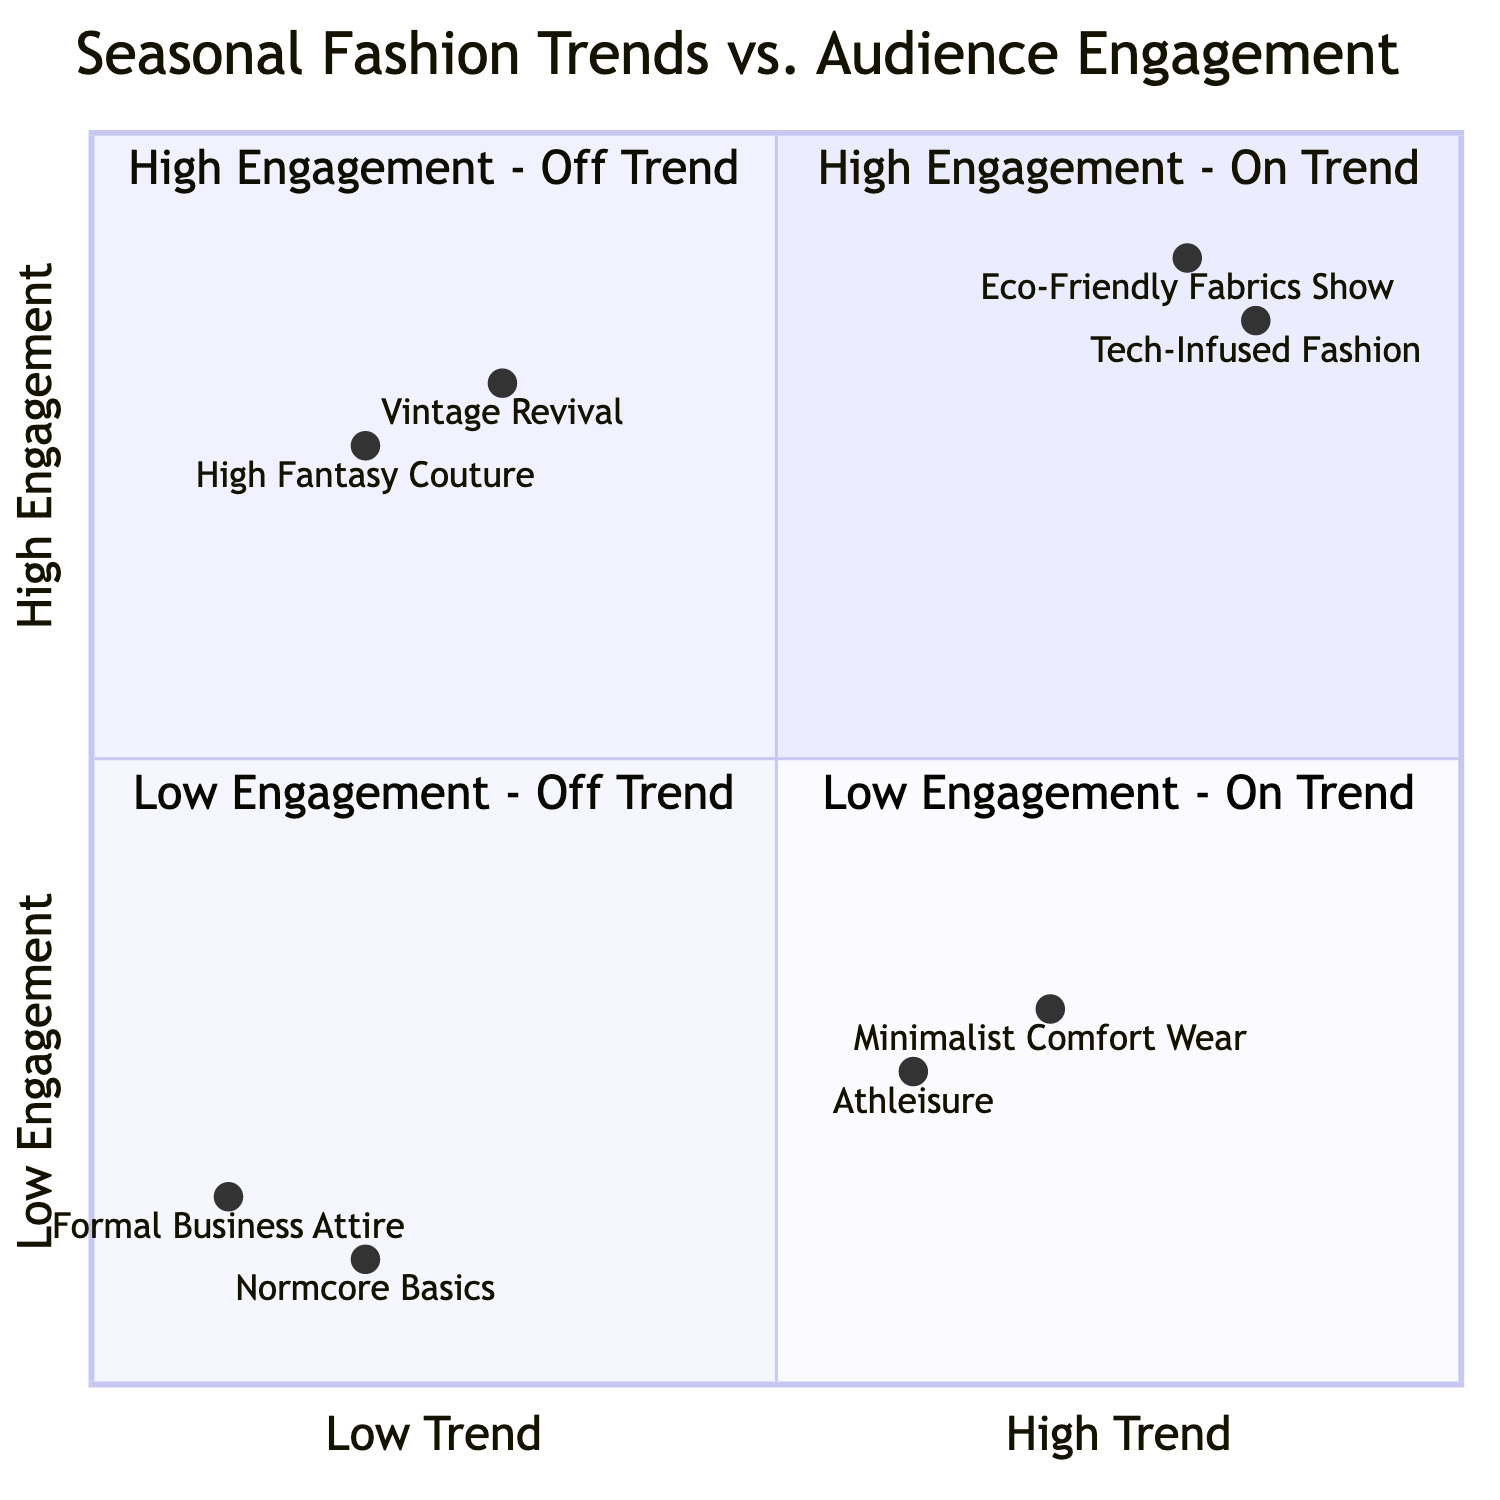What are the two shows located in the "High Engagement - On Trend" quadrant? The "High Engagement - On Trend" quadrant contains two shows, which are identified as "Eco-Friendly Fabrics Show" and "Tech-Infused Fashion." These shows are positioned in the top-right section of the quadrant, indicating that they are both current trends and generating high audience engagement.
Answer: Eco-Friendly Fabrics Show, Tech-Infused Fashion Which show has the highest engagement rate in the "High Engagement - Off Trend" quadrant? The "High Engagement - Off Trend" quadrant features two shows, "Vintage Revival" and "High Fantasy Couture." Comparing their engagement rates, "Vintage Revival" has an engagement rate of 0.8, while "High Fantasy Couture" has a rate of 0.75. Therefore, "Vintage Revival" has the highest engagement rate in this quadrant.
Answer: Vintage Revival How many shows are located in the "Low Engagement - On Trend" quadrant? The "Low Engagement - On Trend" quadrant includes two shows: "Minimalist Comfort Wear" and "Athleisure." Therefore, the number of shows in this quadrant is 2.
Answer: 2 What trend category does the "Formal Business Attire" show fall under? "Formal Business Attire" is located in the "Low Engagement - Off Trend" quadrant, indicating that it does not align with current fashion trends and also produces low engagement from the audience. This classification places it in the bottom-left section of the quadrant.
Answer: Low Engagement - Off Trend Which quadrant features "Normcore Basics"? The "Normcore Basics" show is situated in the "Low Engagement - Off Trend" quadrant. This is the bottom-left quadrant, which includes shows that neither follow current trends nor engage the audience effectively.
Answer: Low Engagement - Off Trend Which of the shows in the "Low Engagement - On Trend" quadrant has the highest engagement rate? Within the "Low Engagement - On Trend" quadrant, the shows are "Minimalist Comfort Wear" and "Athleisure." "Minimalist Comfort Wear" has a higher engagement rate of 0.3 compared to "Athleisure," which has an engagement rate of 0.25. Therefore, "Minimalist Comfort Wear" has the highest engagement rate in this quadrant.
Answer: Minimalist Comfort Wear Which quadrant has shows that are both out of trend and have low engagement? The quadrant titled "Low Engagement - Off Trend" contains shows that are both not following current fashion trends and have low engagement rates. This is represented in the bottom-left section of the quadrant chart, encompassing shows like "Normcore Basics" and "Formal Business Attire."
Answer: Low Engagement - Off Trend What is the engagement rate of the "Tech-Infused Fashion" show? The "Tech-Infused Fashion" show is positioned with an engagement rate of 0.85 in the "High Engagement - On Trend" quadrant, indicating that it generates a significant level of audience interest while adhering to contemporary fashion trends.
Answer: 0.85 